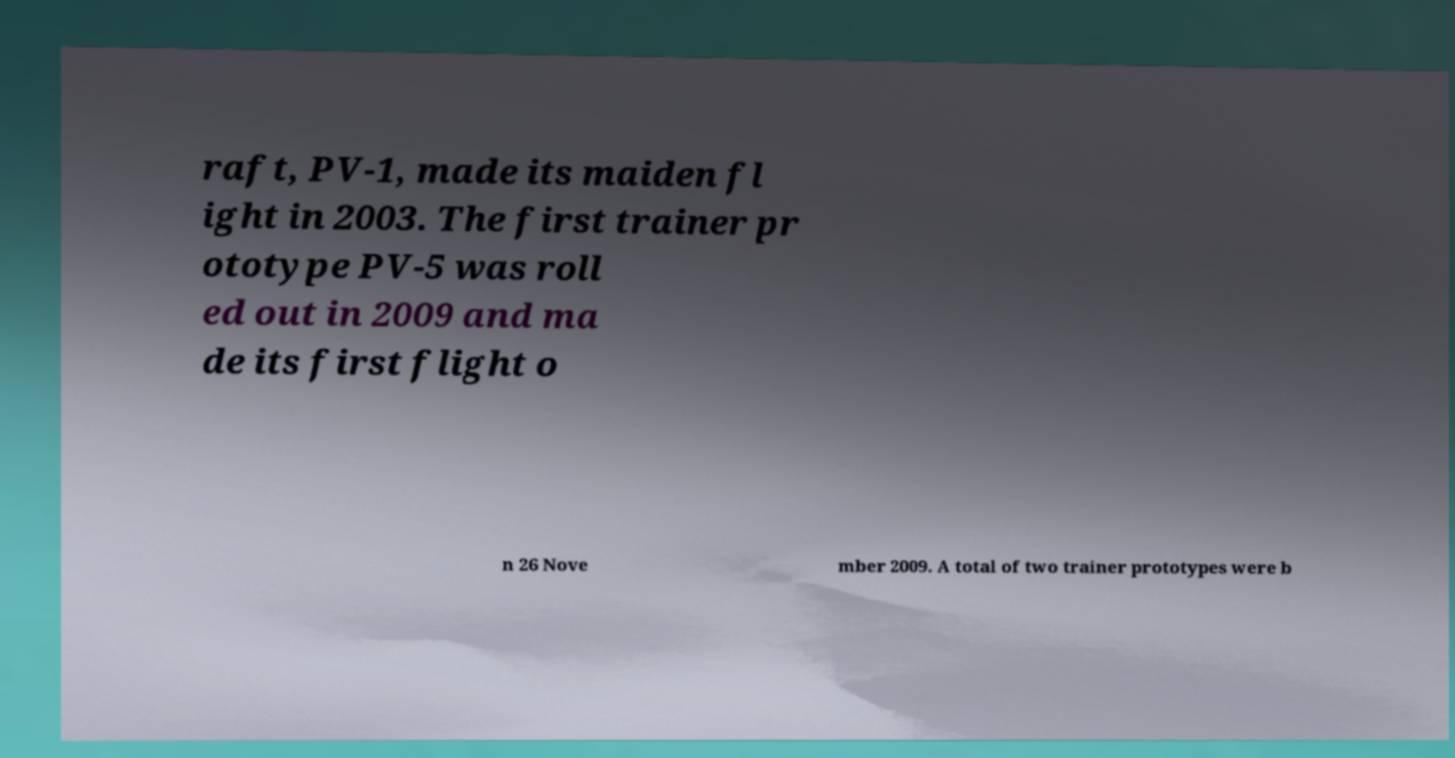Could you extract and type out the text from this image? raft, PV-1, made its maiden fl ight in 2003. The first trainer pr ototype PV-5 was roll ed out in 2009 and ma de its first flight o n 26 Nove mber 2009. A total of two trainer prototypes were b 